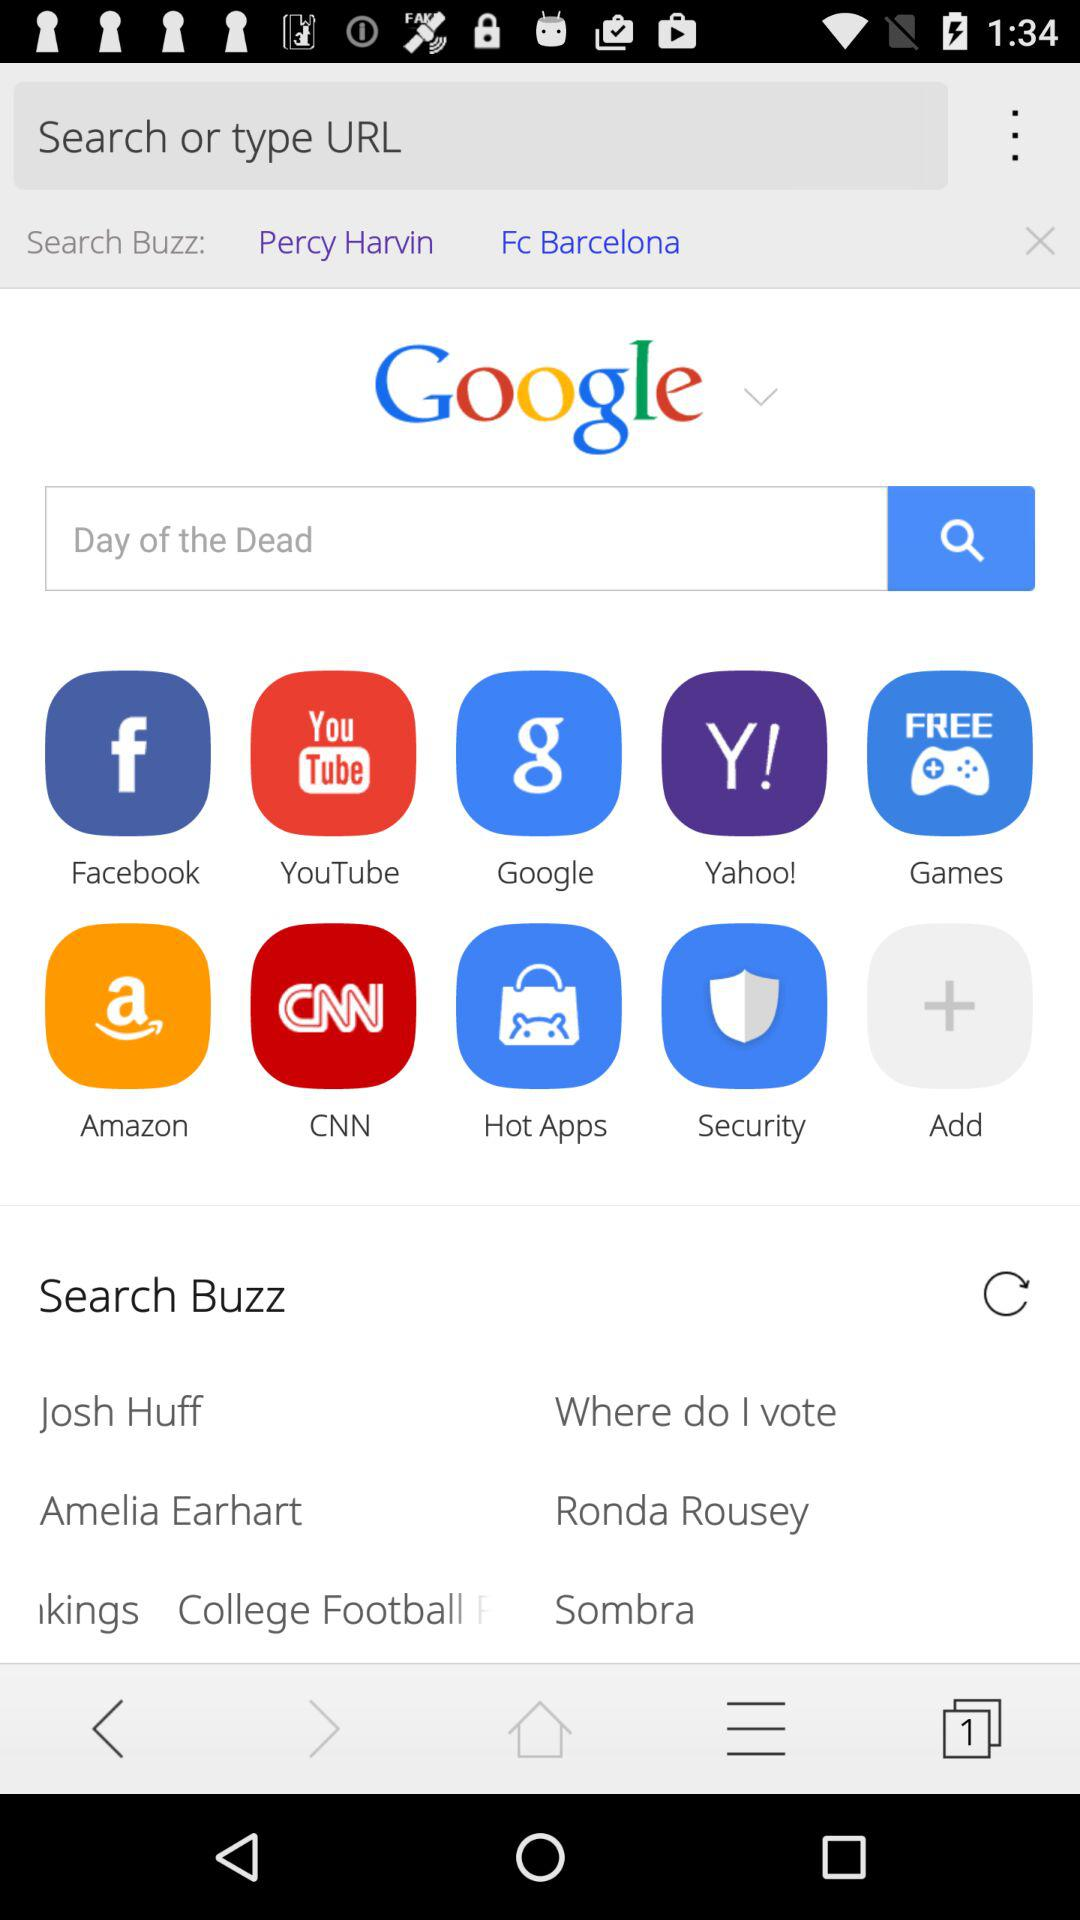What are the available options for "Search Buzz"? The available options are "Josh Huff", "Where do I vote", "Amelia Earhart", "Ronda Rousey", "kings College Football", and "Sombra". 